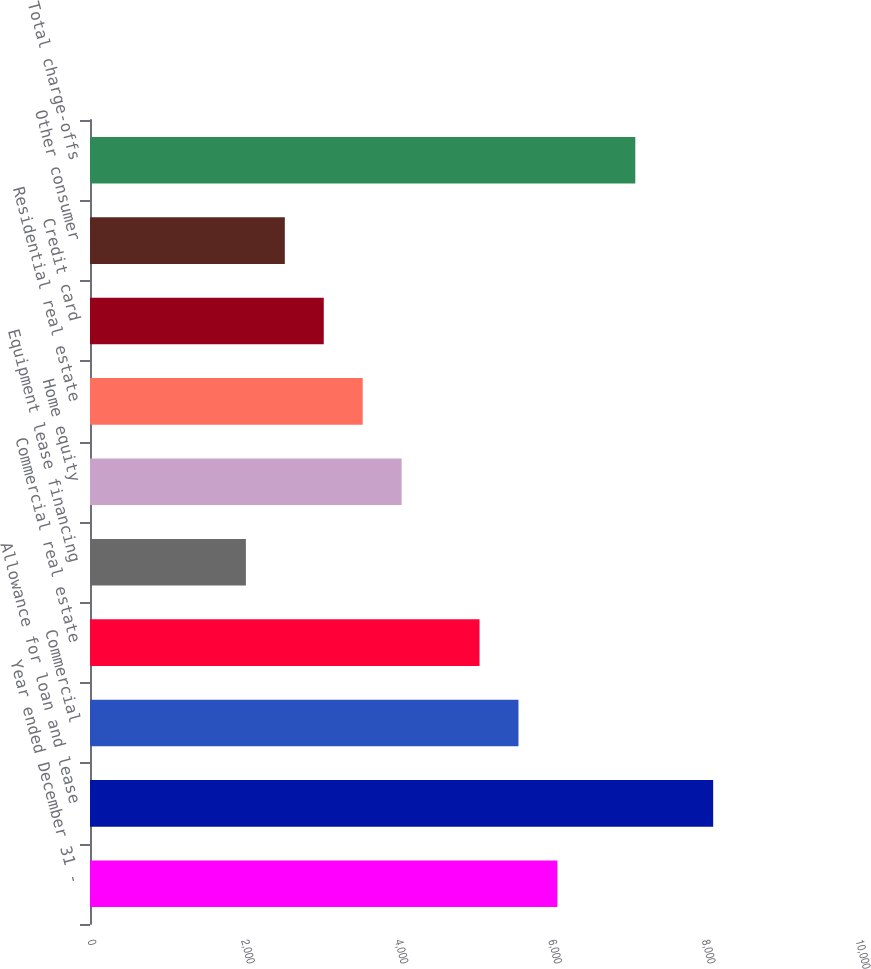Convert chart to OTSL. <chart><loc_0><loc_0><loc_500><loc_500><bar_chart><fcel>Year ended December 31 -<fcel>Allowance for loan and lease<fcel>Commercial<fcel>Commercial real estate<fcel>Equipment lease financing<fcel>Home equity<fcel>Residential real estate<fcel>Credit card<fcel>Other consumer<fcel>Total charge-offs<nl><fcel>6086.11<fcel>8114.27<fcel>5579.07<fcel>5072.03<fcel>2029.79<fcel>4057.95<fcel>3550.91<fcel>3043.87<fcel>2536.83<fcel>7100.19<nl></chart> 